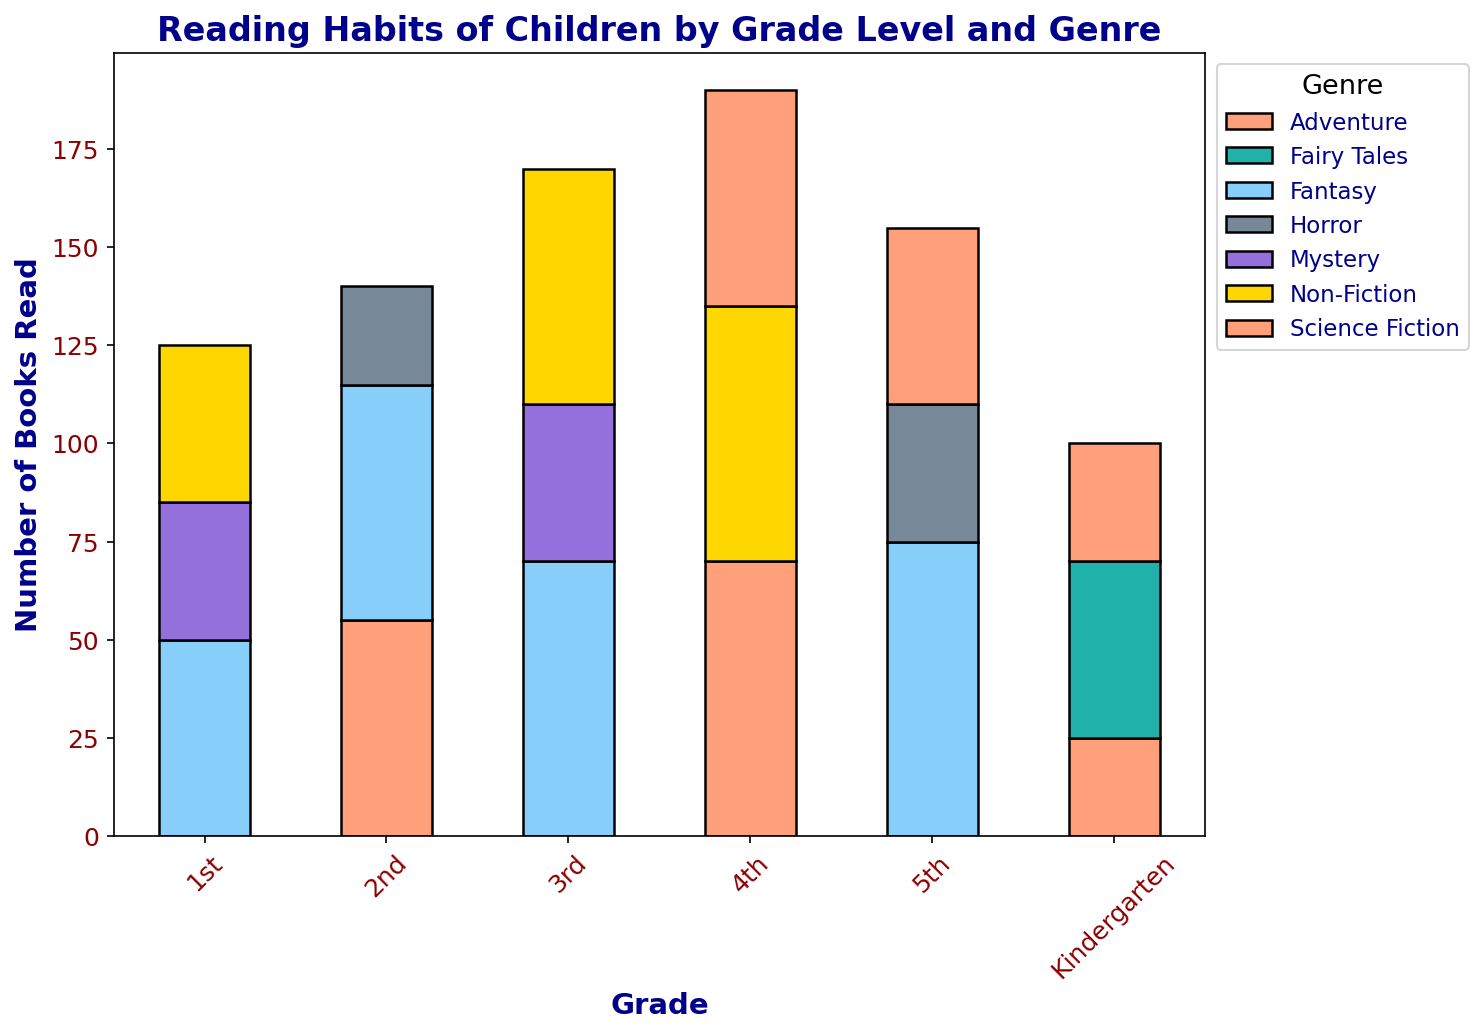Which grade level read the most Fantasy books? Looking at the bars for Fantasy in each grade, the 5th grade has the tallest bar for Fantasy.
Answer: 5th grade How many more Adventure books did 4th graders read compared to Kindergarten? From the figure, 4th graders read 70 Adventure books and Kindergarteners read 25. The difference is 70 - 25.
Answer: 45 Which genre had the lowest number of books read by 2nd graders? For 2nd graders, the lowest bar is for the Horror genre, which is 25 books.
Answer: Horror Compare the number of Non-Fiction books read by 3rd and 4th graders and determine which grade read more and by how much. 3rd graders read 60 Non-Fiction books, and 4th graders read 65. The difference is 65 - 60.
Answer: 4th grade by 5 What is the total number of Science Fiction books read across all grades? Add the Science Fiction counts for Kindergarten (30), 4th (55), and 5th (45). The total is 30 + 55 + 45.
Answer: 130 Which grade had the highest total number of books read across all genres? Sum the counts for each grade and compare. 5th grade total is the highest sum.
Answer: 5th grade Which genre had the most balanced distribution of books read across all grade levels? By observing the heights of the bars for each genre across grades, Non-Fiction visually appears most balanced.
Answer: Non-Fiction Compare the total number of books read in 1st grade to 3rd grade and determine the difference. Sum the book counts for 1st grade (50+35+40) and for 3rd grade (40+70+60). The totals are 125 for 1st grade and 170 for 3rd grade. The difference is 170 - 125.
Answer: 45 